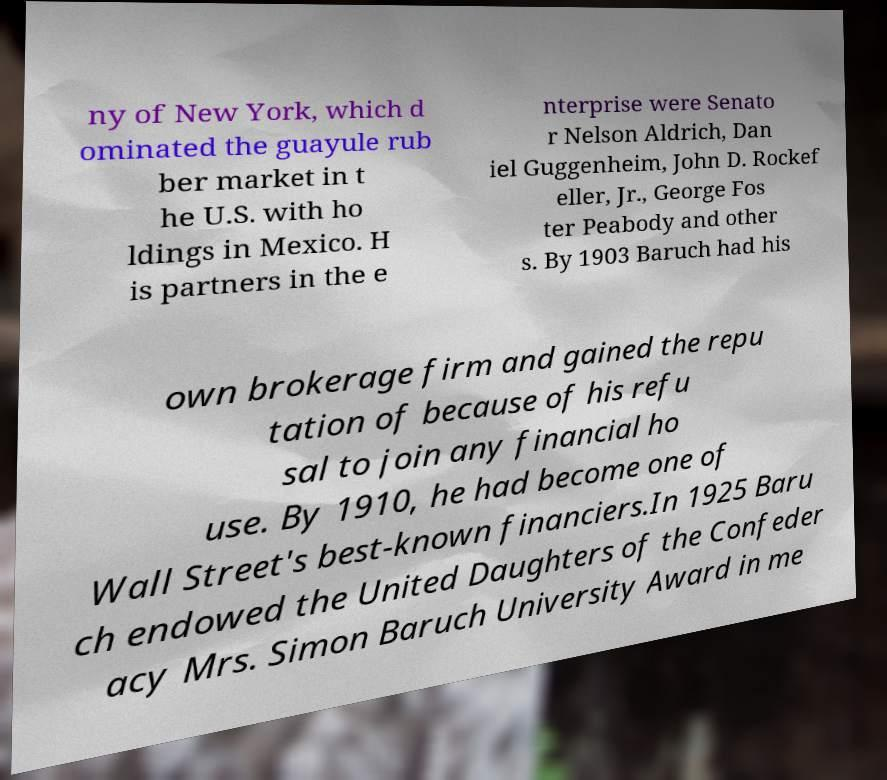Could you extract and type out the text from this image? ny of New York, which d ominated the guayule rub ber market in t he U.S. with ho ldings in Mexico. H is partners in the e nterprise were Senato r Nelson Aldrich, Dan iel Guggenheim, John D. Rockef eller, Jr., George Fos ter Peabody and other s. By 1903 Baruch had his own brokerage firm and gained the repu tation of because of his refu sal to join any financial ho use. By 1910, he had become one of Wall Street's best-known financiers.In 1925 Baru ch endowed the United Daughters of the Confeder acy Mrs. Simon Baruch University Award in me 